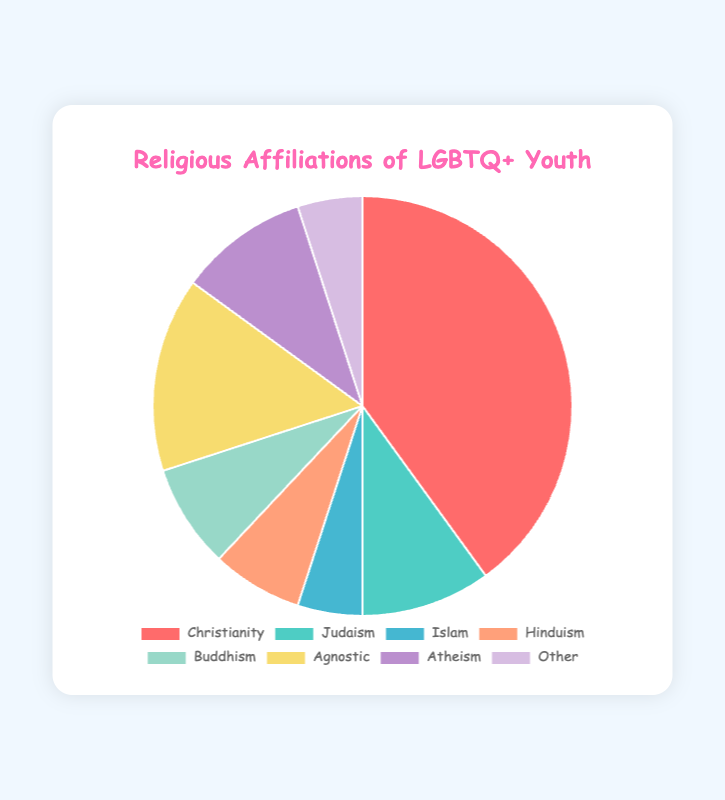What percentage of LGBTQ+ youth identify as Christian? By looking at the pie chart, we can find that the slice representing Christianity is labeled as 40%.
Answer: 40% What is the combined percentage of LGBTQ+ youth identifying as Jewish and Muslim? According to the pie chart, Judaism is 10% and Islam is 5%. Adding these two percentages gives 10% + 5% = 15%.
Answer: 15% Which religious affiliation has a greater percentage of LGBTQ+ youth, Buddhism or Hinduism? The pie chart shows that Buddhism has 8%, while Hinduism has 7%. Therefore, Buddhism has a greater percentage.
Answer: Buddhism Are there more LGBTQ+ youth who are agnostic than atheist? Looking at the pie chart, Agnostic is 15% and Atheism is 10%. Agnostic has a higher percentage than Atheism.
Answer: Yes What's the total percentage of LGBTQ+ youth identifying as either Christian, Agnostic, or Atheist? The pie chart indicates Christianity is 40%, Agnostic is 15%, and Atheism is 10%. Adding these gives 40% + 15% + 10% = 65%.
Answer: 65% What is the smallest religious affiliation group among the LGBTQ+ youth? The pie chart shows that entities with the smallest slice are Islam and Other, both at 5%.
Answer: Islam and Other How does the percentage of LGBTQ+ youth who identify as Jewish compare to those who identify as agnostic? The pie chart shows that Judaism is 10% and Agnostic is 15%. Thus, Agnostic is greater by 5%.
Answer: Agnostic What is the difference between the percentage of LGBTQ+ youth identifying as Christian and those identifying as Hindu? From the chart, Christianity is 40% and Hinduism is 7%. The difference is 40% - 7% = 33%.
Answer: 33% If the pie chart represents 1000 LGBTQ+ youth, approximately how many identify as Buddhist? Given that Buddhism is 8%, we calculate 8% of 1000 which is 0.08 * 1000 = 80 LGBTQ+ youth.
Answer: 80 What is the total percentage of LGBTQ+ youth identifying with non-Abrahamic religions (Hinduism, Buddhism, and Other)? The pie chart shows Hinduism (7%) + Buddhism (8%) + Other (5%) = 20%.
Answer: 20% 